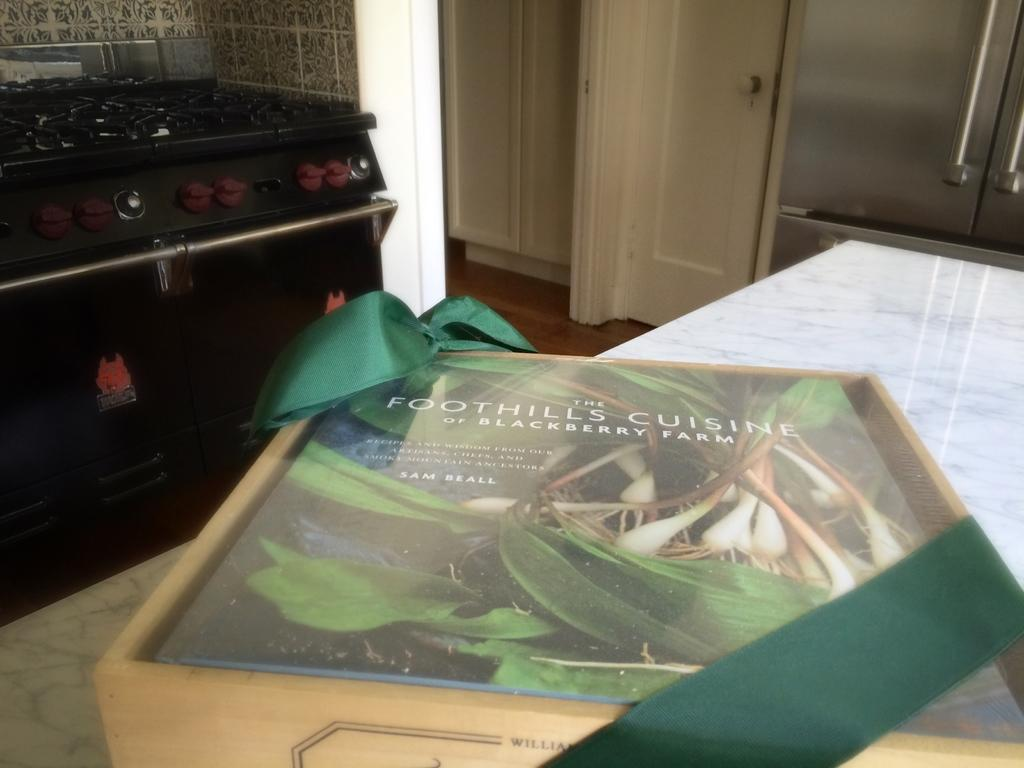<image>
Render a clear and concise summary of the photo. The Foothills Cuisine magazine shows some vegetables on the cover. 